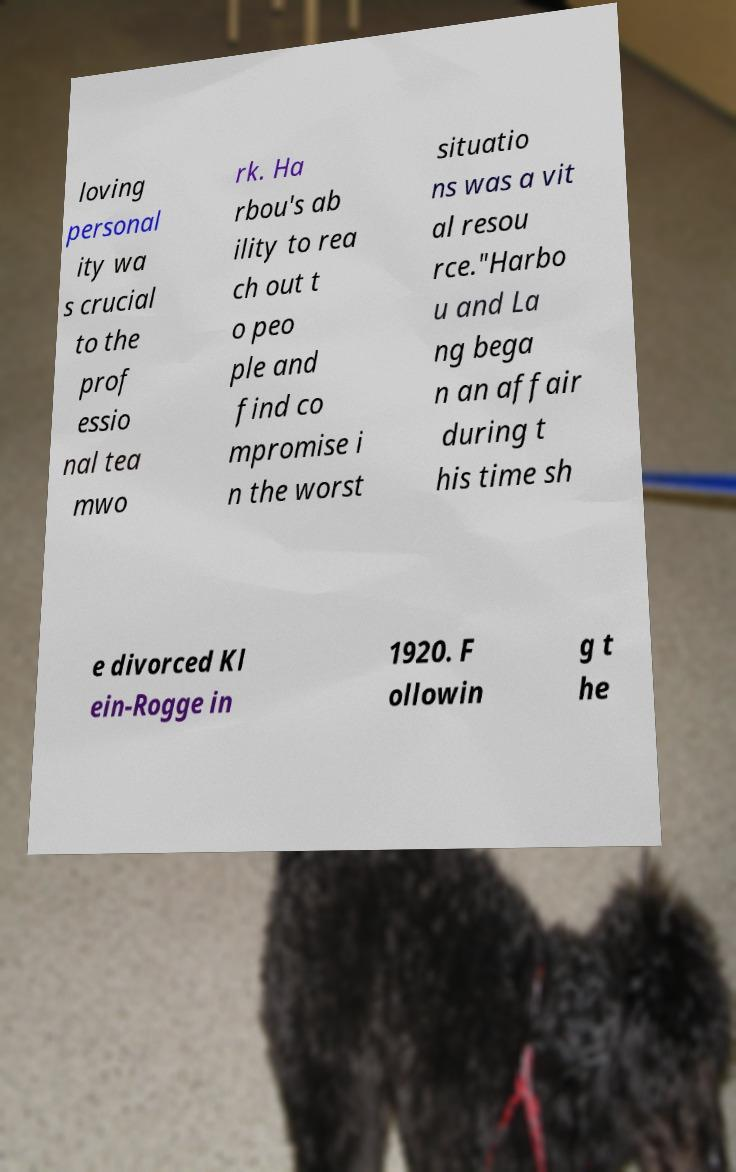There's text embedded in this image that I need extracted. Can you transcribe it verbatim? loving personal ity wa s crucial to the prof essio nal tea mwo rk. Ha rbou's ab ility to rea ch out t o peo ple and find co mpromise i n the worst situatio ns was a vit al resou rce."Harbo u and La ng bega n an affair during t his time sh e divorced Kl ein-Rogge in 1920. F ollowin g t he 